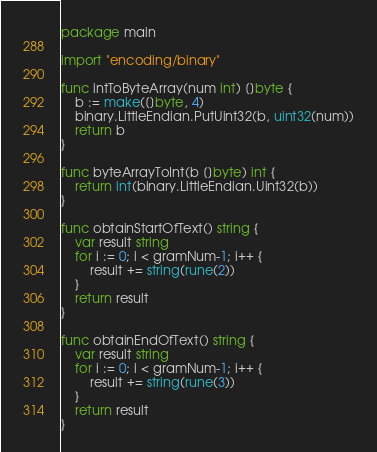<code> <loc_0><loc_0><loc_500><loc_500><_Go_>package main

import "encoding/binary"

func intToByteArray(num int) []byte {
	b := make([]byte, 4)
	binary.LittleEndian.PutUint32(b, uint32(num))
	return b
}

func byteArrayToInt(b []byte) int {
	return int(binary.LittleEndian.Uint32(b))
}

func obtainStartOfText() string {
	var result string
	for i := 0; i < gramNum-1; i++ {
		result += string(rune(2))
	}
	return result
}

func obtainEndOfText() string {
	var result string
	for i := 0; i < gramNum-1; i++ {
		result += string(rune(3))
	}
	return result
}
</code> 